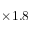Convert formula to latex. <formula><loc_0><loc_0><loc_500><loc_500>\times 1 . 8</formula> 